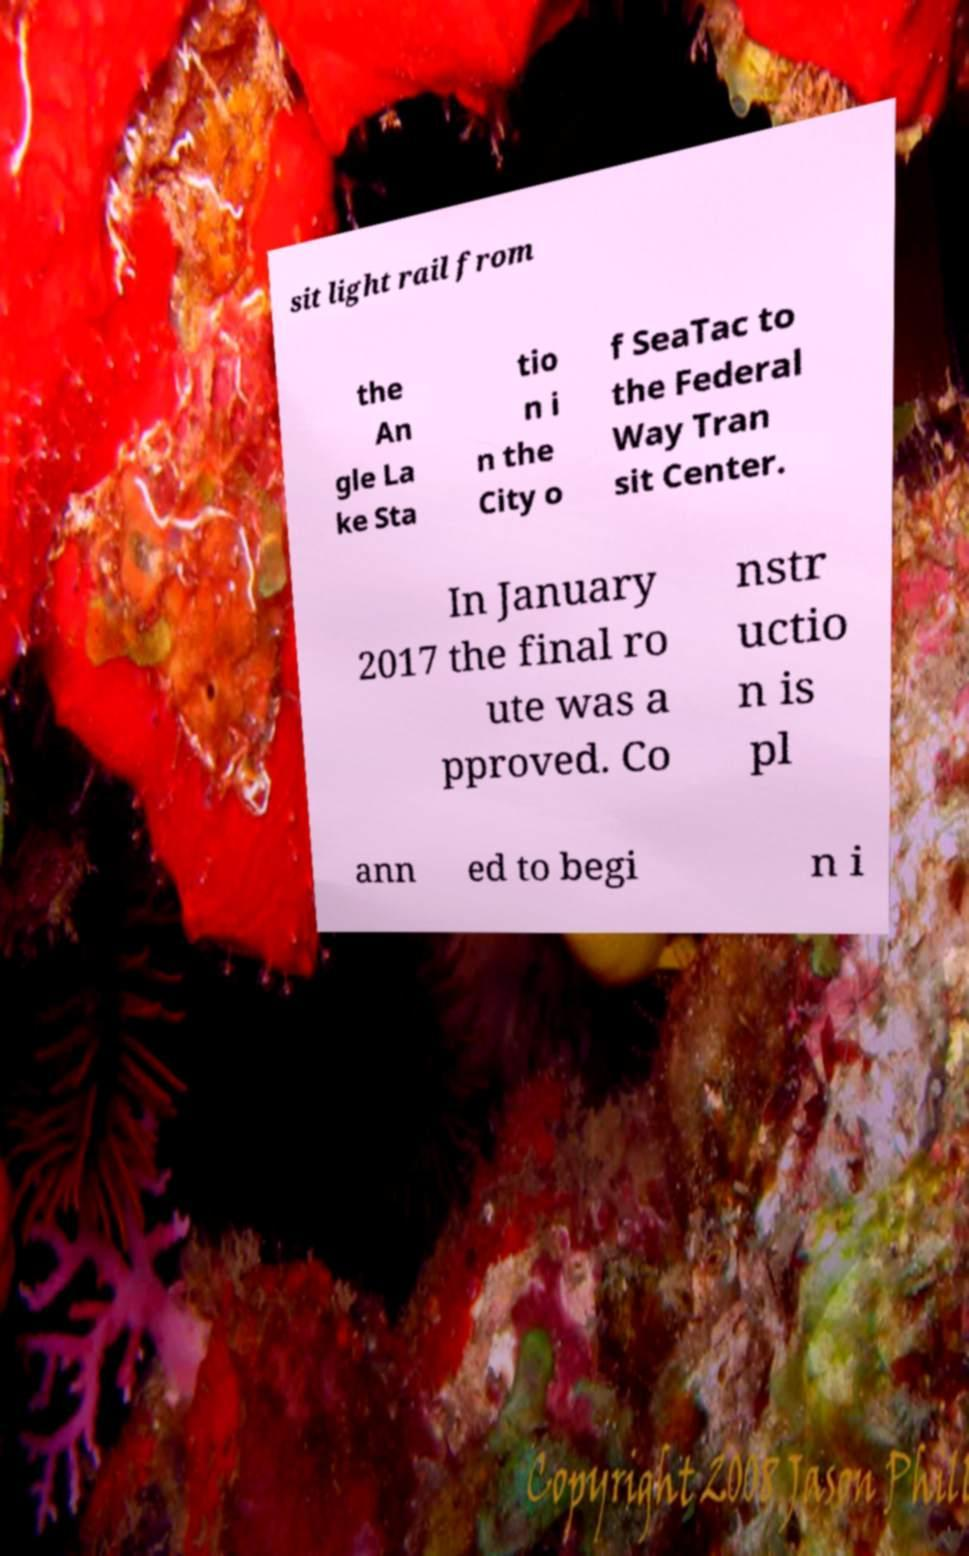For documentation purposes, I need the text within this image transcribed. Could you provide that? sit light rail from the An gle La ke Sta tio n i n the City o f SeaTac to the Federal Way Tran sit Center. In January 2017 the final ro ute was a pproved. Co nstr uctio n is pl ann ed to begi n i 